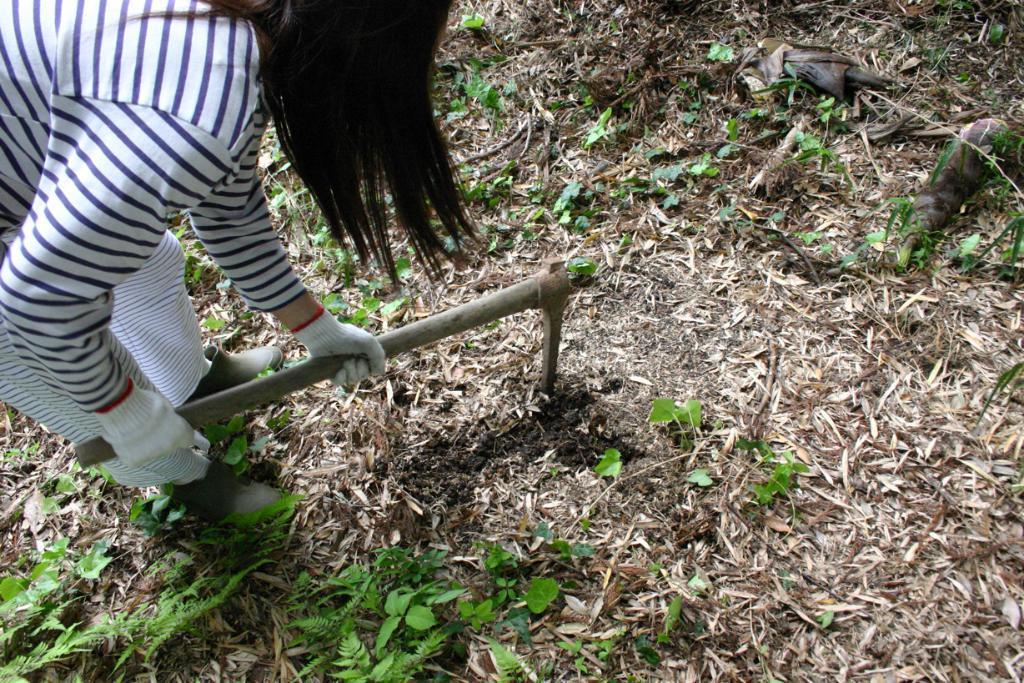Please provide a concise description of this image. In this image we can see a person standing on the ground and holding an axe in the hands. In the background there are plants and shredded leaves on the ground. 